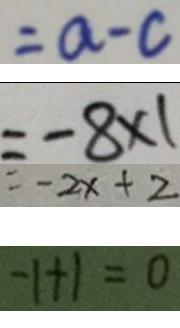<formula> <loc_0><loc_0><loc_500><loc_500>= a - c 
 = - 8 \times 1 
 = - 2 x + 2 
 - 1 + 1 = 0</formula> 